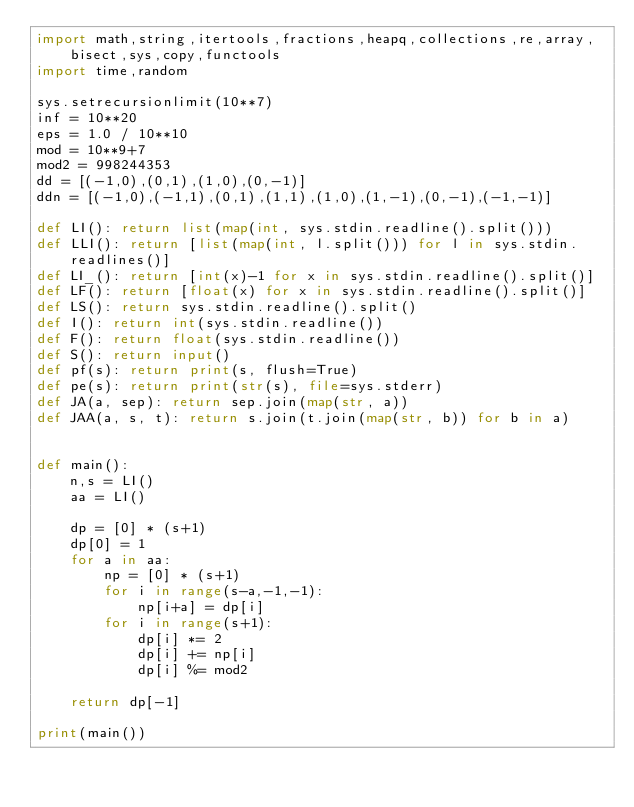Convert code to text. <code><loc_0><loc_0><loc_500><loc_500><_Python_>import math,string,itertools,fractions,heapq,collections,re,array,bisect,sys,copy,functools
import time,random

sys.setrecursionlimit(10**7)
inf = 10**20
eps = 1.0 / 10**10
mod = 10**9+7
mod2 = 998244353
dd = [(-1,0),(0,1),(1,0),(0,-1)]
ddn = [(-1,0),(-1,1),(0,1),(1,1),(1,0),(1,-1),(0,-1),(-1,-1)]

def LI(): return list(map(int, sys.stdin.readline().split()))
def LLI(): return [list(map(int, l.split())) for l in sys.stdin.readlines()]
def LI_(): return [int(x)-1 for x in sys.stdin.readline().split()]
def LF(): return [float(x) for x in sys.stdin.readline().split()]
def LS(): return sys.stdin.readline().split()
def I(): return int(sys.stdin.readline())
def F(): return float(sys.stdin.readline())
def S(): return input()
def pf(s): return print(s, flush=True)
def pe(s): return print(str(s), file=sys.stderr)
def JA(a, sep): return sep.join(map(str, a))
def JAA(a, s, t): return s.join(t.join(map(str, b)) for b in a)


def main():
    n,s = LI()
    aa = LI()

    dp = [0] * (s+1)
    dp[0] = 1
    for a in aa:
        np = [0] * (s+1)
        for i in range(s-a,-1,-1):
            np[i+a] = dp[i]
        for i in range(s+1):
            dp[i] *= 2
            dp[i] += np[i]
            dp[i] %= mod2

    return dp[-1]

print(main())



</code> 